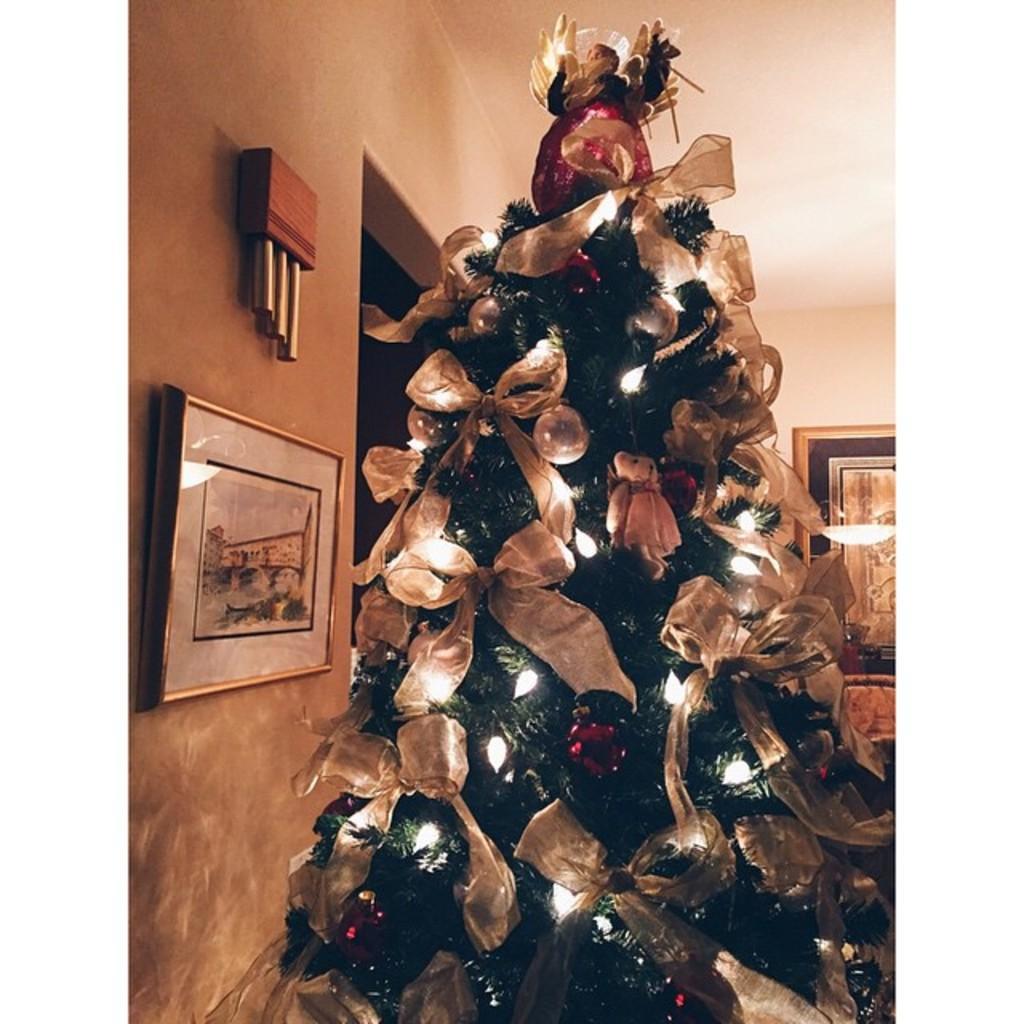In one or two sentences, can you explain what this image depicts? In this picture we can observe a green color Christmas tree decorated with some lights. We can observe some ribbons which are in white color on the tree. There are some photo frames fixed to the wall in this picture. In the background there is a wall. 